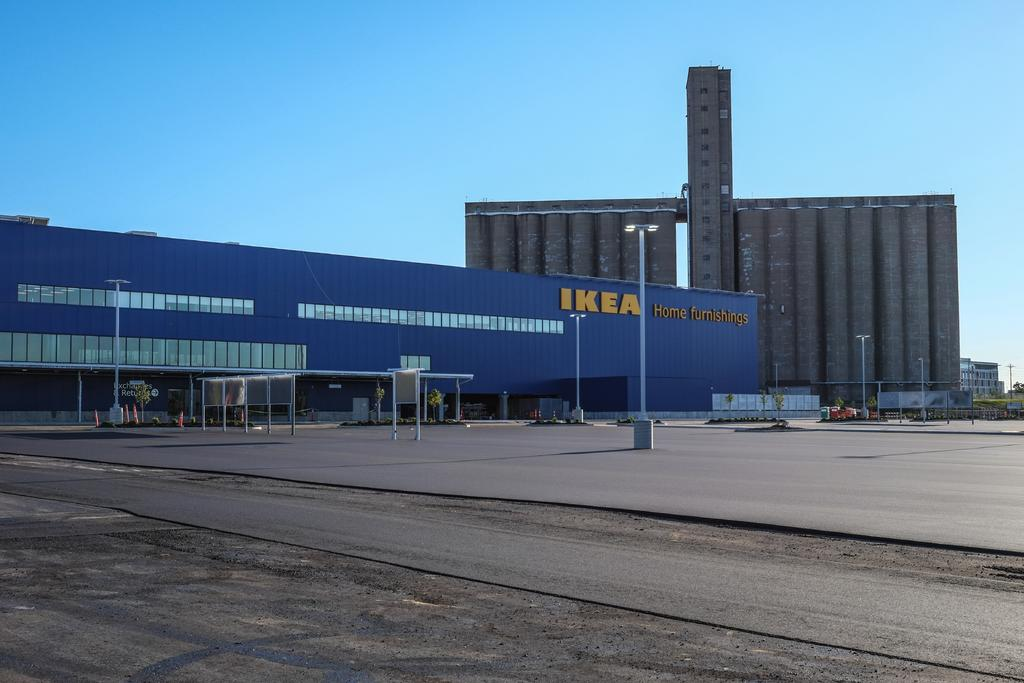What can be seen at the base of the image? The ground is visible in the image. What structures are present in the image? There are poles and buildings visible in the image. What type of vegetation is present in the image? Trees are present in the image. What else can be seen in the image besides the structures and vegetation? There are objects in the image. What is visible in the background of the image? The sky is visible in the background of the image. What type of glove is being used to start the car in the image? There is no car or glove present in the image. What type of journey is being depicted in the image? The image does not depict a journey; it shows a scene with various structures, vegetation, and objects. 